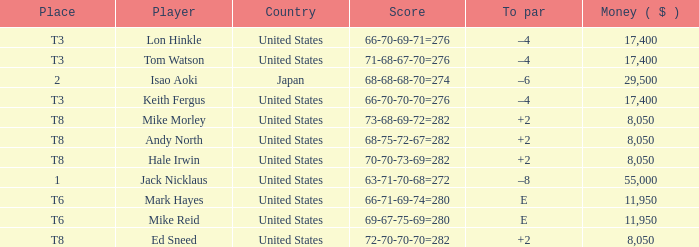What country has the score og 66-70-69-71=276? United States. 